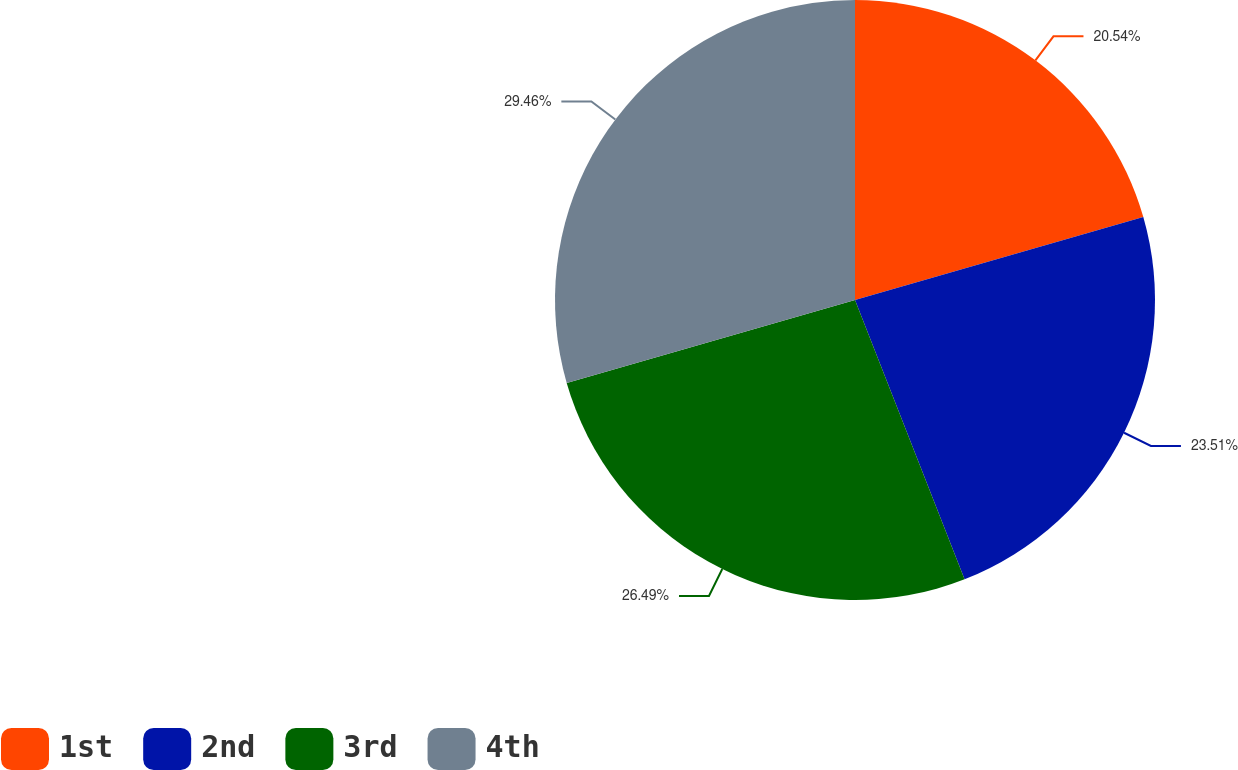Convert chart. <chart><loc_0><loc_0><loc_500><loc_500><pie_chart><fcel>1st<fcel>2nd<fcel>3rd<fcel>4th<nl><fcel>20.54%<fcel>23.51%<fcel>26.49%<fcel>29.46%<nl></chart> 